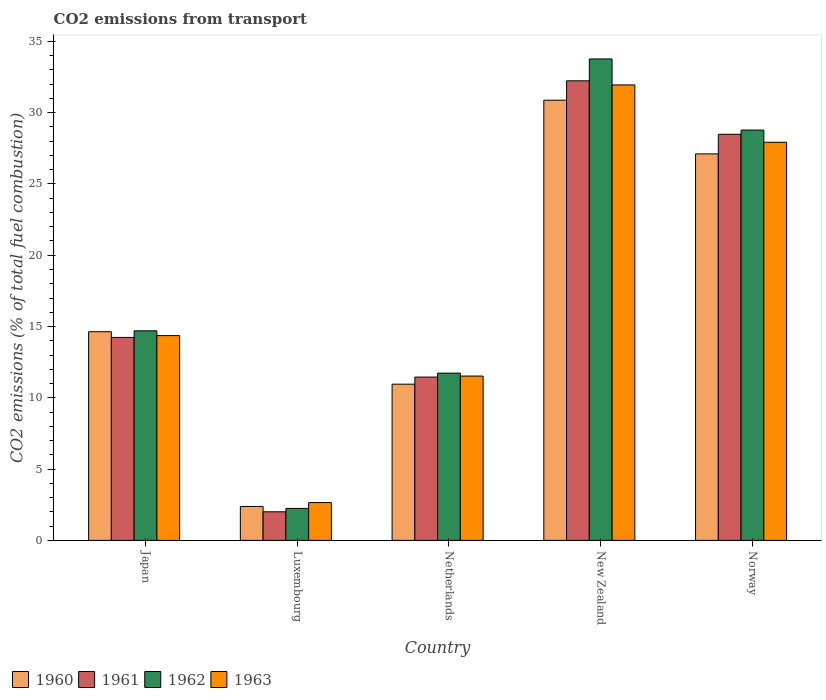How many different coloured bars are there?
Your answer should be very brief. 4. Are the number of bars on each tick of the X-axis equal?
Provide a succinct answer. Yes. What is the label of the 2nd group of bars from the left?
Provide a short and direct response. Luxembourg. What is the total CO2 emitted in 1963 in Luxembourg?
Your answer should be very brief. 2.65. Across all countries, what is the maximum total CO2 emitted in 1961?
Offer a very short reply. 32.23. Across all countries, what is the minimum total CO2 emitted in 1963?
Provide a short and direct response. 2.65. In which country was the total CO2 emitted in 1960 maximum?
Ensure brevity in your answer.  New Zealand. In which country was the total CO2 emitted in 1963 minimum?
Ensure brevity in your answer.  Luxembourg. What is the total total CO2 emitted in 1960 in the graph?
Offer a terse response. 85.95. What is the difference between the total CO2 emitted in 1961 in New Zealand and that in Norway?
Provide a short and direct response. 3.75. What is the difference between the total CO2 emitted in 1963 in Luxembourg and the total CO2 emitted in 1961 in Japan?
Your answer should be very brief. -11.58. What is the average total CO2 emitted in 1963 per country?
Offer a terse response. 17.68. What is the difference between the total CO2 emitted of/in 1963 and total CO2 emitted of/in 1962 in Luxembourg?
Make the answer very short. 0.41. What is the ratio of the total CO2 emitted in 1960 in Luxembourg to that in Netherlands?
Ensure brevity in your answer.  0.22. Is the total CO2 emitted in 1963 in New Zealand less than that in Norway?
Provide a short and direct response. No. Is the difference between the total CO2 emitted in 1963 in Japan and New Zealand greater than the difference between the total CO2 emitted in 1962 in Japan and New Zealand?
Your answer should be compact. Yes. What is the difference between the highest and the second highest total CO2 emitted in 1961?
Your response must be concise. 3.75. What is the difference between the highest and the lowest total CO2 emitted in 1963?
Offer a terse response. 29.29. In how many countries, is the total CO2 emitted in 1963 greater than the average total CO2 emitted in 1963 taken over all countries?
Provide a succinct answer. 2. What does the 3rd bar from the left in Norway represents?
Your answer should be very brief. 1962. What does the 3rd bar from the right in Luxembourg represents?
Your answer should be compact. 1961. Is it the case that in every country, the sum of the total CO2 emitted in 1963 and total CO2 emitted in 1962 is greater than the total CO2 emitted in 1960?
Ensure brevity in your answer.  Yes. How many countries are there in the graph?
Ensure brevity in your answer.  5. What is the difference between two consecutive major ticks on the Y-axis?
Provide a succinct answer. 5. Are the values on the major ticks of Y-axis written in scientific E-notation?
Provide a short and direct response. No. Does the graph contain grids?
Provide a succinct answer. No. How many legend labels are there?
Offer a terse response. 4. How are the legend labels stacked?
Your answer should be compact. Horizontal. What is the title of the graph?
Provide a short and direct response. CO2 emissions from transport. What is the label or title of the X-axis?
Give a very brief answer. Country. What is the label or title of the Y-axis?
Make the answer very short. CO2 emissions (% of total fuel combustion). What is the CO2 emissions (% of total fuel combustion) in 1960 in Japan?
Your answer should be very brief. 14.64. What is the CO2 emissions (% of total fuel combustion) in 1961 in Japan?
Your answer should be compact. 14.23. What is the CO2 emissions (% of total fuel combustion) in 1962 in Japan?
Give a very brief answer. 14.7. What is the CO2 emissions (% of total fuel combustion) in 1963 in Japan?
Offer a terse response. 14.36. What is the CO2 emissions (% of total fuel combustion) of 1960 in Luxembourg?
Provide a succinct answer. 2.38. What is the CO2 emissions (% of total fuel combustion) of 1961 in Luxembourg?
Provide a succinct answer. 2.01. What is the CO2 emissions (% of total fuel combustion) in 1962 in Luxembourg?
Your response must be concise. 2.24. What is the CO2 emissions (% of total fuel combustion) of 1963 in Luxembourg?
Ensure brevity in your answer.  2.65. What is the CO2 emissions (% of total fuel combustion) in 1960 in Netherlands?
Make the answer very short. 10.96. What is the CO2 emissions (% of total fuel combustion) of 1961 in Netherlands?
Provide a succinct answer. 11.45. What is the CO2 emissions (% of total fuel combustion) of 1962 in Netherlands?
Your response must be concise. 11.73. What is the CO2 emissions (% of total fuel combustion) in 1963 in Netherlands?
Offer a terse response. 11.53. What is the CO2 emissions (% of total fuel combustion) of 1960 in New Zealand?
Your answer should be compact. 30.87. What is the CO2 emissions (% of total fuel combustion) in 1961 in New Zealand?
Provide a short and direct response. 32.23. What is the CO2 emissions (% of total fuel combustion) of 1962 in New Zealand?
Your answer should be compact. 33.77. What is the CO2 emissions (% of total fuel combustion) of 1963 in New Zealand?
Ensure brevity in your answer.  31.94. What is the CO2 emissions (% of total fuel combustion) of 1960 in Norway?
Offer a very short reply. 27.11. What is the CO2 emissions (% of total fuel combustion) in 1961 in Norway?
Keep it short and to the point. 28.48. What is the CO2 emissions (% of total fuel combustion) of 1962 in Norway?
Offer a very short reply. 28.78. What is the CO2 emissions (% of total fuel combustion) in 1963 in Norway?
Give a very brief answer. 27.92. Across all countries, what is the maximum CO2 emissions (% of total fuel combustion) in 1960?
Your answer should be very brief. 30.87. Across all countries, what is the maximum CO2 emissions (% of total fuel combustion) of 1961?
Offer a terse response. 32.23. Across all countries, what is the maximum CO2 emissions (% of total fuel combustion) in 1962?
Keep it short and to the point. 33.77. Across all countries, what is the maximum CO2 emissions (% of total fuel combustion) of 1963?
Give a very brief answer. 31.94. Across all countries, what is the minimum CO2 emissions (% of total fuel combustion) in 1960?
Give a very brief answer. 2.38. Across all countries, what is the minimum CO2 emissions (% of total fuel combustion) of 1961?
Provide a succinct answer. 2.01. Across all countries, what is the minimum CO2 emissions (% of total fuel combustion) in 1962?
Ensure brevity in your answer.  2.24. Across all countries, what is the minimum CO2 emissions (% of total fuel combustion) of 1963?
Make the answer very short. 2.65. What is the total CO2 emissions (% of total fuel combustion) in 1960 in the graph?
Offer a terse response. 85.95. What is the total CO2 emissions (% of total fuel combustion) of 1961 in the graph?
Give a very brief answer. 88.41. What is the total CO2 emissions (% of total fuel combustion) in 1962 in the graph?
Keep it short and to the point. 91.22. What is the total CO2 emissions (% of total fuel combustion) of 1963 in the graph?
Provide a short and direct response. 88.41. What is the difference between the CO2 emissions (% of total fuel combustion) of 1960 in Japan and that in Luxembourg?
Provide a short and direct response. 12.26. What is the difference between the CO2 emissions (% of total fuel combustion) of 1961 in Japan and that in Luxembourg?
Your answer should be very brief. 12.23. What is the difference between the CO2 emissions (% of total fuel combustion) of 1962 in Japan and that in Luxembourg?
Ensure brevity in your answer.  12.45. What is the difference between the CO2 emissions (% of total fuel combustion) of 1963 in Japan and that in Luxembourg?
Your answer should be compact. 11.71. What is the difference between the CO2 emissions (% of total fuel combustion) in 1960 in Japan and that in Netherlands?
Offer a terse response. 3.68. What is the difference between the CO2 emissions (% of total fuel combustion) of 1961 in Japan and that in Netherlands?
Offer a terse response. 2.78. What is the difference between the CO2 emissions (% of total fuel combustion) of 1962 in Japan and that in Netherlands?
Offer a terse response. 2.97. What is the difference between the CO2 emissions (% of total fuel combustion) of 1963 in Japan and that in Netherlands?
Offer a very short reply. 2.84. What is the difference between the CO2 emissions (% of total fuel combustion) of 1960 in Japan and that in New Zealand?
Your response must be concise. -16.24. What is the difference between the CO2 emissions (% of total fuel combustion) in 1961 in Japan and that in New Zealand?
Provide a succinct answer. -18. What is the difference between the CO2 emissions (% of total fuel combustion) of 1962 in Japan and that in New Zealand?
Offer a terse response. -19.07. What is the difference between the CO2 emissions (% of total fuel combustion) in 1963 in Japan and that in New Zealand?
Your answer should be compact. -17.58. What is the difference between the CO2 emissions (% of total fuel combustion) of 1960 in Japan and that in Norway?
Provide a short and direct response. -12.47. What is the difference between the CO2 emissions (% of total fuel combustion) of 1961 in Japan and that in Norway?
Provide a short and direct response. -14.25. What is the difference between the CO2 emissions (% of total fuel combustion) in 1962 in Japan and that in Norway?
Keep it short and to the point. -14.08. What is the difference between the CO2 emissions (% of total fuel combustion) in 1963 in Japan and that in Norway?
Give a very brief answer. -13.56. What is the difference between the CO2 emissions (% of total fuel combustion) of 1960 in Luxembourg and that in Netherlands?
Keep it short and to the point. -8.58. What is the difference between the CO2 emissions (% of total fuel combustion) in 1961 in Luxembourg and that in Netherlands?
Keep it short and to the point. -9.45. What is the difference between the CO2 emissions (% of total fuel combustion) in 1962 in Luxembourg and that in Netherlands?
Your response must be concise. -9.49. What is the difference between the CO2 emissions (% of total fuel combustion) in 1963 in Luxembourg and that in Netherlands?
Offer a very short reply. -8.87. What is the difference between the CO2 emissions (% of total fuel combustion) in 1960 in Luxembourg and that in New Zealand?
Offer a terse response. -28.5. What is the difference between the CO2 emissions (% of total fuel combustion) in 1961 in Luxembourg and that in New Zealand?
Provide a succinct answer. -30.23. What is the difference between the CO2 emissions (% of total fuel combustion) of 1962 in Luxembourg and that in New Zealand?
Your answer should be very brief. -31.52. What is the difference between the CO2 emissions (% of total fuel combustion) in 1963 in Luxembourg and that in New Zealand?
Make the answer very short. -29.29. What is the difference between the CO2 emissions (% of total fuel combustion) in 1960 in Luxembourg and that in Norway?
Make the answer very short. -24.73. What is the difference between the CO2 emissions (% of total fuel combustion) of 1961 in Luxembourg and that in Norway?
Offer a terse response. -26.48. What is the difference between the CO2 emissions (% of total fuel combustion) in 1962 in Luxembourg and that in Norway?
Make the answer very short. -26.53. What is the difference between the CO2 emissions (% of total fuel combustion) of 1963 in Luxembourg and that in Norway?
Provide a succinct answer. -25.27. What is the difference between the CO2 emissions (% of total fuel combustion) in 1960 in Netherlands and that in New Zealand?
Give a very brief answer. -19.92. What is the difference between the CO2 emissions (% of total fuel combustion) of 1961 in Netherlands and that in New Zealand?
Your answer should be compact. -20.78. What is the difference between the CO2 emissions (% of total fuel combustion) in 1962 in Netherlands and that in New Zealand?
Provide a short and direct response. -22.04. What is the difference between the CO2 emissions (% of total fuel combustion) of 1963 in Netherlands and that in New Zealand?
Offer a very short reply. -20.42. What is the difference between the CO2 emissions (% of total fuel combustion) of 1960 in Netherlands and that in Norway?
Provide a short and direct response. -16.15. What is the difference between the CO2 emissions (% of total fuel combustion) of 1961 in Netherlands and that in Norway?
Your response must be concise. -17.03. What is the difference between the CO2 emissions (% of total fuel combustion) in 1962 in Netherlands and that in Norway?
Ensure brevity in your answer.  -17.05. What is the difference between the CO2 emissions (% of total fuel combustion) in 1963 in Netherlands and that in Norway?
Give a very brief answer. -16.4. What is the difference between the CO2 emissions (% of total fuel combustion) in 1960 in New Zealand and that in Norway?
Provide a short and direct response. 3.77. What is the difference between the CO2 emissions (% of total fuel combustion) in 1961 in New Zealand and that in Norway?
Your answer should be compact. 3.75. What is the difference between the CO2 emissions (% of total fuel combustion) in 1962 in New Zealand and that in Norway?
Provide a short and direct response. 4.99. What is the difference between the CO2 emissions (% of total fuel combustion) in 1963 in New Zealand and that in Norway?
Provide a short and direct response. 4.02. What is the difference between the CO2 emissions (% of total fuel combustion) in 1960 in Japan and the CO2 emissions (% of total fuel combustion) in 1961 in Luxembourg?
Give a very brief answer. 12.63. What is the difference between the CO2 emissions (% of total fuel combustion) of 1960 in Japan and the CO2 emissions (% of total fuel combustion) of 1962 in Luxembourg?
Offer a terse response. 12.39. What is the difference between the CO2 emissions (% of total fuel combustion) of 1960 in Japan and the CO2 emissions (% of total fuel combustion) of 1963 in Luxembourg?
Ensure brevity in your answer.  11.98. What is the difference between the CO2 emissions (% of total fuel combustion) in 1961 in Japan and the CO2 emissions (% of total fuel combustion) in 1962 in Luxembourg?
Make the answer very short. 11.99. What is the difference between the CO2 emissions (% of total fuel combustion) in 1961 in Japan and the CO2 emissions (% of total fuel combustion) in 1963 in Luxembourg?
Ensure brevity in your answer.  11.58. What is the difference between the CO2 emissions (% of total fuel combustion) of 1962 in Japan and the CO2 emissions (% of total fuel combustion) of 1963 in Luxembourg?
Keep it short and to the point. 12.05. What is the difference between the CO2 emissions (% of total fuel combustion) of 1960 in Japan and the CO2 emissions (% of total fuel combustion) of 1961 in Netherlands?
Provide a short and direct response. 3.18. What is the difference between the CO2 emissions (% of total fuel combustion) in 1960 in Japan and the CO2 emissions (% of total fuel combustion) in 1962 in Netherlands?
Your answer should be compact. 2.91. What is the difference between the CO2 emissions (% of total fuel combustion) of 1960 in Japan and the CO2 emissions (% of total fuel combustion) of 1963 in Netherlands?
Give a very brief answer. 3.11. What is the difference between the CO2 emissions (% of total fuel combustion) of 1961 in Japan and the CO2 emissions (% of total fuel combustion) of 1962 in Netherlands?
Provide a succinct answer. 2.5. What is the difference between the CO2 emissions (% of total fuel combustion) of 1961 in Japan and the CO2 emissions (% of total fuel combustion) of 1963 in Netherlands?
Your answer should be very brief. 2.71. What is the difference between the CO2 emissions (% of total fuel combustion) in 1962 in Japan and the CO2 emissions (% of total fuel combustion) in 1963 in Netherlands?
Offer a terse response. 3.17. What is the difference between the CO2 emissions (% of total fuel combustion) of 1960 in Japan and the CO2 emissions (% of total fuel combustion) of 1961 in New Zealand?
Ensure brevity in your answer.  -17.6. What is the difference between the CO2 emissions (% of total fuel combustion) in 1960 in Japan and the CO2 emissions (% of total fuel combustion) in 1962 in New Zealand?
Offer a terse response. -19.13. What is the difference between the CO2 emissions (% of total fuel combustion) in 1960 in Japan and the CO2 emissions (% of total fuel combustion) in 1963 in New Zealand?
Give a very brief answer. -17.31. What is the difference between the CO2 emissions (% of total fuel combustion) in 1961 in Japan and the CO2 emissions (% of total fuel combustion) in 1962 in New Zealand?
Your answer should be very brief. -19.53. What is the difference between the CO2 emissions (% of total fuel combustion) in 1961 in Japan and the CO2 emissions (% of total fuel combustion) in 1963 in New Zealand?
Provide a short and direct response. -17.71. What is the difference between the CO2 emissions (% of total fuel combustion) of 1962 in Japan and the CO2 emissions (% of total fuel combustion) of 1963 in New Zealand?
Ensure brevity in your answer.  -17.25. What is the difference between the CO2 emissions (% of total fuel combustion) in 1960 in Japan and the CO2 emissions (% of total fuel combustion) in 1961 in Norway?
Give a very brief answer. -13.85. What is the difference between the CO2 emissions (% of total fuel combustion) of 1960 in Japan and the CO2 emissions (% of total fuel combustion) of 1962 in Norway?
Provide a succinct answer. -14.14. What is the difference between the CO2 emissions (% of total fuel combustion) in 1960 in Japan and the CO2 emissions (% of total fuel combustion) in 1963 in Norway?
Provide a short and direct response. -13.29. What is the difference between the CO2 emissions (% of total fuel combustion) in 1961 in Japan and the CO2 emissions (% of total fuel combustion) in 1962 in Norway?
Provide a succinct answer. -14.54. What is the difference between the CO2 emissions (% of total fuel combustion) in 1961 in Japan and the CO2 emissions (% of total fuel combustion) in 1963 in Norway?
Provide a succinct answer. -13.69. What is the difference between the CO2 emissions (% of total fuel combustion) of 1962 in Japan and the CO2 emissions (% of total fuel combustion) of 1963 in Norway?
Keep it short and to the point. -13.23. What is the difference between the CO2 emissions (% of total fuel combustion) in 1960 in Luxembourg and the CO2 emissions (% of total fuel combustion) in 1961 in Netherlands?
Ensure brevity in your answer.  -9.08. What is the difference between the CO2 emissions (% of total fuel combustion) in 1960 in Luxembourg and the CO2 emissions (% of total fuel combustion) in 1962 in Netherlands?
Make the answer very short. -9.35. What is the difference between the CO2 emissions (% of total fuel combustion) of 1960 in Luxembourg and the CO2 emissions (% of total fuel combustion) of 1963 in Netherlands?
Provide a short and direct response. -9.15. What is the difference between the CO2 emissions (% of total fuel combustion) of 1961 in Luxembourg and the CO2 emissions (% of total fuel combustion) of 1962 in Netherlands?
Give a very brief answer. -9.72. What is the difference between the CO2 emissions (% of total fuel combustion) of 1961 in Luxembourg and the CO2 emissions (% of total fuel combustion) of 1963 in Netherlands?
Your answer should be very brief. -9.52. What is the difference between the CO2 emissions (% of total fuel combustion) in 1962 in Luxembourg and the CO2 emissions (% of total fuel combustion) in 1963 in Netherlands?
Offer a very short reply. -9.28. What is the difference between the CO2 emissions (% of total fuel combustion) in 1960 in Luxembourg and the CO2 emissions (% of total fuel combustion) in 1961 in New Zealand?
Provide a succinct answer. -29.86. What is the difference between the CO2 emissions (% of total fuel combustion) of 1960 in Luxembourg and the CO2 emissions (% of total fuel combustion) of 1962 in New Zealand?
Give a very brief answer. -31.39. What is the difference between the CO2 emissions (% of total fuel combustion) in 1960 in Luxembourg and the CO2 emissions (% of total fuel combustion) in 1963 in New Zealand?
Keep it short and to the point. -29.57. What is the difference between the CO2 emissions (% of total fuel combustion) of 1961 in Luxembourg and the CO2 emissions (% of total fuel combustion) of 1962 in New Zealand?
Offer a very short reply. -31.76. What is the difference between the CO2 emissions (% of total fuel combustion) of 1961 in Luxembourg and the CO2 emissions (% of total fuel combustion) of 1963 in New Zealand?
Ensure brevity in your answer.  -29.94. What is the difference between the CO2 emissions (% of total fuel combustion) of 1962 in Luxembourg and the CO2 emissions (% of total fuel combustion) of 1963 in New Zealand?
Provide a short and direct response. -29.7. What is the difference between the CO2 emissions (% of total fuel combustion) of 1960 in Luxembourg and the CO2 emissions (% of total fuel combustion) of 1961 in Norway?
Make the answer very short. -26.1. What is the difference between the CO2 emissions (% of total fuel combustion) in 1960 in Luxembourg and the CO2 emissions (% of total fuel combustion) in 1962 in Norway?
Provide a succinct answer. -26.4. What is the difference between the CO2 emissions (% of total fuel combustion) in 1960 in Luxembourg and the CO2 emissions (% of total fuel combustion) in 1963 in Norway?
Offer a terse response. -25.54. What is the difference between the CO2 emissions (% of total fuel combustion) in 1961 in Luxembourg and the CO2 emissions (% of total fuel combustion) in 1962 in Norway?
Offer a very short reply. -26.77. What is the difference between the CO2 emissions (% of total fuel combustion) of 1961 in Luxembourg and the CO2 emissions (% of total fuel combustion) of 1963 in Norway?
Provide a short and direct response. -25.92. What is the difference between the CO2 emissions (% of total fuel combustion) in 1962 in Luxembourg and the CO2 emissions (% of total fuel combustion) in 1963 in Norway?
Keep it short and to the point. -25.68. What is the difference between the CO2 emissions (% of total fuel combustion) of 1960 in Netherlands and the CO2 emissions (% of total fuel combustion) of 1961 in New Zealand?
Provide a short and direct response. -21.28. What is the difference between the CO2 emissions (% of total fuel combustion) of 1960 in Netherlands and the CO2 emissions (% of total fuel combustion) of 1962 in New Zealand?
Provide a succinct answer. -22.81. What is the difference between the CO2 emissions (% of total fuel combustion) in 1960 in Netherlands and the CO2 emissions (% of total fuel combustion) in 1963 in New Zealand?
Ensure brevity in your answer.  -20.99. What is the difference between the CO2 emissions (% of total fuel combustion) in 1961 in Netherlands and the CO2 emissions (% of total fuel combustion) in 1962 in New Zealand?
Offer a very short reply. -22.31. What is the difference between the CO2 emissions (% of total fuel combustion) in 1961 in Netherlands and the CO2 emissions (% of total fuel combustion) in 1963 in New Zealand?
Keep it short and to the point. -20.49. What is the difference between the CO2 emissions (% of total fuel combustion) of 1962 in Netherlands and the CO2 emissions (% of total fuel combustion) of 1963 in New Zealand?
Keep it short and to the point. -20.21. What is the difference between the CO2 emissions (% of total fuel combustion) of 1960 in Netherlands and the CO2 emissions (% of total fuel combustion) of 1961 in Norway?
Offer a very short reply. -17.53. What is the difference between the CO2 emissions (% of total fuel combustion) in 1960 in Netherlands and the CO2 emissions (% of total fuel combustion) in 1962 in Norway?
Your response must be concise. -17.82. What is the difference between the CO2 emissions (% of total fuel combustion) in 1960 in Netherlands and the CO2 emissions (% of total fuel combustion) in 1963 in Norway?
Give a very brief answer. -16.97. What is the difference between the CO2 emissions (% of total fuel combustion) in 1961 in Netherlands and the CO2 emissions (% of total fuel combustion) in 1962 in Norway?
Ensure brevity in your answer.  -17.32. What is the difference between the CO2 emissions (% of total fuel combustion) in 1961 in Netherlands and the CO2 emissions (% of total fuel combustion) in 1963 in Norway?
Provide a short and direct response. -16.47. What is the difference between the CO2 emissions (% of total fuel combustion) in 1962 in Netherlands and the CO2 emissions (% of total fuel combustion) in 1963 in Norway?
Offer a very short reply. -16.19. What is the difference between the CO2 emissions (% of total fuel combustion) in 1960 in New Zealand and the CO2 emissions (% of total fuel combustion) in 1961 in Norway?
Offer a terse response. 2.39. What is the difference between the CO2 emissions (% of total fuel combustion) in 1960 in New Zealand and the CO2 emissions (% of total fuel combustion) in 1962 in Norway?
Your response must be concise. 2.1. What is the difference between the CO2 emissions (% of total fuel combustion) in 1960 in New Zealand and the CO2 emissions (% of total fuel combustion) in 1963 in Norway?
Your answer should be very brief. 2.95. What is the difference between the CO2 emissions (% of total fuel combustion) in 1961 in New Zealand and the CO2 emissions (% of total fuel combustion) in 1962 in Norway?
Your response must be concise. 3.46. What is the difference between the CO2 emissions (% of total fuel combustion) in 1961 in New Zealand and the CO2 emissions (% of total fuel combustion) in 1963 in Norway?
Ensure brevity in your answer.  4.31. What is the difference between the CO2 emissions (% of total fuel combustion) in 1962 in New Zealand and the CO2 emissions (% of total fuel combustion) in 1963 in Norway?
Ensure brevity in your answer.  5.84. What is the average CO2 emissions (% of total fuel combustion) of 1960 per country?
Offer a terse response. 17.19. What is the average CO2 emissions (% of total fuel combustion) of 1961 per country?
Offer a terse response. 17.68. What is the average CO2 emissions (% of total fuel combustion) of 1962 per country?
Your answer should be very brief. 18.24. What is the average CO2 emissions (% of total fuel combustion) of 1963 per country?
Give a very brief answer. 17.68. What is the difference between the CO2 emissions (% of total fuel combustion) of 1960 and CO2 emissions (% of total fuel combustion) of 1961 in Japan?
Ensure brevity in your answer.  0.4. What is the difference between the CO2 emissions (% of total fuel combustion) in 1960 and CO2 emissions (% of total fuel combustion) in 1962 in Japan?
Make the answer very short. -0.06. What is the difference between the CO2 emissions (% of total fuel combustion) of 1960 and CO2 emissions (% of total fuel combustion) of 1963 in Japan?
Your response must be concise. 0.27. What is the difference between the CO2 emissions (% of total fuel combustion) of 1961 and CO2 emissions (% of total fuel combustion) of 1962 in Japan?
Provide a succinct answer. -0.46. What is the difference between the CO2 emissions (% of total fuel combustion) in 1961 and CO2 emissions (% of total fuel combustion) in 1963 in Japan?
Provide a short and direct response. -0.13. What is the difference between the CO2 emissions (% of total fuel combustion) of 1962 and CO2 emissions (% of total fuel combustion) of 1963 in Japan?
Provide a short and direct response. 0.33. What is the difference between the CO2 emissions (% of total fuel combustion) in 1960 and CO2 emissions (% of total fuel combustion) in 1961 in Luxembourg?
Ensure brevity in your answer.  0.37. What is the difference between the CO2 emissions (% of total fuel combustion) of 1960 and CO2 emissions (% of total fuel combustion) of 1962 in Luxembourg?
Give a very brief answer. 0.14. What is the difference between the CO2 emissions (% of total fuel combustion) in 1960 and CO2 emissions (% of total fuel combustion) in 1963 in Luxembourg?
Your answer should be very brief. -0.27. What is the difference between the CO2 emissions (% of total fuel combustion) of 1961 and CO2 emissions (% of total fuel combustion) of 1962 in Luxembourg?
Offer a terse response. -0.24. What is the difference between the CO2 emissions (% of total fuel combustion) in 1961 and CO2 emissions (% of total fuel combustion) in 1963 in Luxembourg?
Provide a short and direct response. -0.65. What is the difference between the CO2 emissions (% of total fuel combustion) in 1962 and CO2 emissions (% of total fuel combustion) in 1963 in Luxembourg?
Offer a very short reply. -0.41. What is the difference between the CO2 emissions (% of total fuel combustion) in 1960 and CO2 emissions (% of total fuel combustion) in 1961 in Netherlands?
Provide a short and direct response. -0.5. What is the difference between the CO2 emissions (% of total fuel combustion) in 1960 and CO2 emissions (% of total fuel combustion) in 1962 in Netherlands?
Provide a short and direct response. -0.77. What is the difference between the CO2 emissions (% of total fuel combustion) in 1960 and CO2 emissions (% of total fuel combustion) in 1963 in Netherlands?
Keep it short and to the point. -0.57. What is the difference between the CO2 emissions (% of total fuel combustion) of 1961 and CO2 emissions (% of total fuel combustion) of 1962 in Netherlands?
Your answer should be very brief. -0.28. What is the difference between the CO2 emissions (% of total fuel combustion) of 1961 and CO2 emissions (% of total fuel combustion) of 1963 in Netherlands?
Your answer should be very brief. -0.07. What is the difference between the CO2 emissions (% of total fuel combustion) of 1962 and CO2 emissions (% of total fuel combustion) of 1963 in Netherlands?
Ensure brevity in your answer.  0.21. What is the difference between the CO2 emissions (% of total fuel combustion) in 1960 and CO2 emissions (% of total fuel combustion) in 1961 in New Zealand?
Offer a terse response. -1.36. What is the difference between the CO2 emissions (% of total fuel combustion) in 1960 and CO2 emissions (% of total fuel combustion) in 1962 in New Zealand?
Offer a very short reply. -2.89. What is the difference between the CO2 emissions (% of total fuel combustion) of 1960 and CO2 emissions (% of total fuel combustion) of 1963 in New Zealand?
Offer a very short reply. -1.07. What is the difference between the CO2 emissions (% of total fuel combustion) of 1961 and CO2 emissions (% of total fuel combustion) of 1962 in New Zealand?
Make the answer very short. -1.53. What is the difference between the CO2 emissions (% of total fuel combustion) of 1961 and CO2 emissions (% of total fuel combustion) of 1963 in New Zealand?
Your answer should be compact. 0.29. What is the difference between the CO2 emissions (% of total fuel combustion) in 1962 and CO2 emissions (% of total fuel combustion) in 1963 in New Zealand?
Offer a very short reply. 1.82. What is the difference between the CO2 emissions (% of total fuel combustion) of 1960 and CO2 emissions (% of total fuel combustion) of 1961 in Norway?
Your answer should be very brief. -1.38. What is the difference between the CO2 emissions (% of total fuel combustion) in 1960 and CO2 emissions (% of total fuel combustion) in 1962 in Norway?
Offer a very short reply. -1.67. What is the difference between the CO2 emissions (% of total fuel combustion) of 1960 and CO2 emissions (% of total fuel combustion) of 1963 in Norway?
Ensure brevity in your answer.  -0.82. What is the difference between the CO2 emissions (% of total fuel combustion) of 1961 and CO2 emissions (% of total fuel combustion) of 1962 in Norway?
Your answer should be very brief. -0.29. What is the difference between the CO2 emissions (% of total fuel combustion) in 1961 and CO2 emissions (% of total fuel combustion) in 1963 in Norway?
Keep it short and to the point. 0.56. What is the difference between the CO2 emissions (% of total fuel combustion) of 1962 and CO2 emissions (% of total fuel combustion) of 1963 in Norway?
Provide a short and direct response. 0.85. What is the ratio of the CO2 emissions (% of total fuel combustion) in 1960 in Japan to that in Luxembourg?
Your answer should be compact. 6.15. What is the ratio of the CO2 emissions (% of total fuel combustion) in 1961 in Japan to that in Luxembourg?
Your answer should be very brief. 7.1. What is the ratio of the CO2 emissions (% of total fuel combustion) in 1962 in Japan to that in Luxembourg?
Offer a terse response. 6.55. What is the ratio of the CO2 emissions (% of total fuel combustion) in 1963 in Japan to that in Luxembourg?
Offer a terse response. 5.41. What is the ratio of the CO2 emissions (% of total fuel combustion) in 1960 in Japan to that in Netherlands?
Offer a terse response. 1.34. What is the ratio of the CO2 emissions (% of total fuel combustion) in 1961 in Japan to that in Netherlands?
Offer a very short reply. 1.24. What is the ratio of the CO2 emissions (% of total fuel combustion) in 1962 in Japan to that in Netherlands?
Give a very brief answer. 1.25. What is the ratio of the CO2 emissions (% of total fuel combustion) in 1963 in Japan to that in Netherlands?
Keep it short and to the point. 1.25. What is the ratio of the CO2 emissions (% of total fuel combustion) of 1960 in Japan to that in New Zealand?
Give a very brief answer. 0.47. What is the ratio of the CO2 emissions (% of total fuel combustion) of 1961 in Japan to that in New Zealand?
Your answer should be compact. 0.44. What is the ratio of the CO2 emissions (% of total fuel combustion) in 1962 in Japan to that in New Zealand?
Your answer should be very brief. 0.44. What is the ratio of the CO2 emissions (% of total fuel combustion) of 1963 in Japan to that in New Zealand?
Your answer should be compact. 0.45. What is the ratio of the CO2 emissions (% of total fuel combustion) in 1960 in Japan to that in Norway?
Give a very brief answer. 0.54. What is the ratio of the CO2 emissions (% of total fuel combustion) of 1961 in Japan to that in Norway?
Your response must be concise. 0.5. What is the ratio of the CO2 emissions (% of total fuel combustion) in 1962 in Japan to that in Norway?
Make the answer very short. 0.51. What is the ratio of the CO2 emissions (% of total fuel combustion) in 1963 in Japan to that in Norway?
Provide a short and direct response. 0.51. What is the ratio of the CO2 emissions (% of total fuel combustion) of 1960 in Luxembourg to that in Netherlands?
Make the answer very short. 0.22. What is the ratio of the CO2 emissions (% of total fuel combustion) in 1961 in Luxembourg to that in Netherlands?
Offer a very short reply. 0.18. What is the ratio of the CO2 emissions (% of total fuel combustion) in 1962 in Luxembourg to that in Netherlands?
Make the answer very short. 0.19. What is the ratio of the CO2 emissions (% of total fuel combustion) in 1963 in Luxembourg to that in Netherlands?
Give a very brief answer. 0.23. What is the ratio of the CO2 emissions (% of total fuel combustion) of 1960 in Luxembourg to that in New Zealand?
Offer a terse response. 0.08. What is the ratio of the CO2 emissions (% of total fuel combustion) in 1961 in Luxembourg to that in New Zealand?
Provide a succinct answer. 0.06. What is the ratio of the CO2 emissions (% of total fuel combustion) of 1962 in Luxembourg to that in New Zealand?
Offer a terse response. 0.07. What is the ratio of the CO2 emissions (% of total fuel combustion) of 1963 in Luxembourg to that in New Zealand?
Your answer should be very brief. 0.08. What is the ratio of the CO2 emissions (% of total fuel combustion) of 1960 in Luxembourg to that in Norway?
Your answer should be compact. 0.09. What is the ratio of the CO2 emissions (% of total fuel combustion) in 1961 in Luxembourg to that in Norway?
Offer a terse response. 0.07. What is the ratio of the CO2 emissions (% of total fuel combustion) in 1962 in Luxembourg to that in Norway?
Provide a short and direct response. 0.08. What is the ratio of the CO2 emissions (% of total fuel combustion) of 1963 in Luxembourg to that in Norway?
Your answer should be very brief. 0.1. What is the ratio of the CO2 emissions (% of total fuel combustion) of 1960 in Netherlands to that in New Zealand?
Your answer should be very brief. 0.35. What is the ratio of the CO2 emissions (% of total fuel combustion) in 1961 in Netherlands to that in New Zealand?
Provide a short and direct response. 0.36. What is the ratio of the CO2 emissions (% of total fuel combustion) in 1962 in Netherlands to that in New Zealand?
Offer a very short reply. 0.35. What is the ratio of the CO2 emissions (% of total fuel combustion) in 1963 in Netherlands to that in New Zealand?
Your answer should be compact. 0.36. What is the ratio of the CO2 emissions (% of total fuel combustion) in 1960 in Netherlands to that in Norway?
Your answer should be very brief. 0.4. What is the ratio of the CO2 emissions (% of total fuel combustion) of 1961 in Netherlands to that in Norway?
Ensure brevity in your answer.  0.4. What is the ratio of the CO2 emissions (% of total fuel combustion) of 1962 in Netherlands to that in Norway?
Your answer should be compact. 0.41. What is the ratio of the CO2 emissions (% of total fuel combustion) of 1963 in Netherlands to that in Norway?
Offer a very short reply. 0.41. What is the ratio of the CO2 emissions (% of total fuel combustion) in 1960 in New Zealand to that in Norway?
Your answer should be very brief. 1.14. What is the ratio of the CO2 emissions (% of total fuel combustion) of 1961 in New Zealand to that in Norway?
Your response must be concise. 1.13. What is the ratio of the CO2 emissions (% of total fuel combustion) of 1962 in New Zealand to that in Norway?
Your answer should be compact. 1.17. What is the ratio of the CO2 emissions (% of total fuel combustion) in 1963 in New Zealand to that in Norway?
Provide a short and direct response. 1.14. What is the difference between the highest and the second highest CO2 emissions (% of total fuel combustion) in 1960?
Keep it short and to the point. 3.77. What is the difference between the highest and the second highest CO2 emissions (% of total fuel combustion) of 1961?
Provide a short and direct response. 3.75. What is the difference between the highest and the second highest CO2 emissions (% of total fuel combustion) of 1962?
Ensure brevity in your answer.  4.99. What is the difference between the highest and the second highest CO2 emissions (% of total fuel combustion) of 1963?
Make the answer very short. 4.02. What is the difference between the highest and the lowest CO2 emissions (% of total fuel combustion) in 1960?
Give a very brief answer. 28.5. What is the difference between the highest and the lowest CO2 emissions (% of total fuel combustion) in 1961?
Your response must be concise. 30.23. What is the difference between the highest and the lowest CO2 emissions (% of total fuel combustion) in 1962?
Provide a short and direct response. 31.52. What is the difference between the highest and the lowest CO2 emissions (% of total fuel combustion) of 1963?
Offer a very short reply. 29.29. 